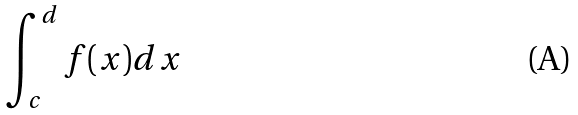<formula> <loc_0><loc_0><loc_500><loc_500>\int _ { c } ^ { d } f ( x ) d x</formula> 